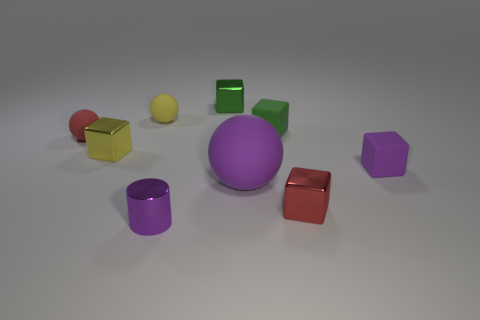Is the number of yellow metallic things greater than the number of large green things?
Give a very brief answer. Yes. There is a tiny matte sphere that is to the right of the yellow metallic object; what is its color?
Provide a succinct answer. Yellow. What size is the matte object that is both behind the small red sphere and to the right of the purple metallic cylinder?
Your answer should be very brief. Small. How many brown shiny cylinders are the same size as the purple matte cube?
Your answer should be very brief. 0. There is a red thing that is the same shape as the green metallic object; what is its material?
Your response must be concise. Metal. Is the shape of the yellow metal object the same as the big rubber object?
Provide a succinct answer. No. There is a small cylinder; how many red things are left of it?
Ensure brevity in your answer.  1. The tiny purple thing to the left of the small green metallic block right of the yellow ball is what shape?
Offer a very short reply. Cylinder. The tiny yellow thing that is made of the same material as the purple cube is what shape?
Give a very brief answer. Sphere. There is a metal block that is in front of the tiny yellow shiny block; does it have the same size as the green object that is left of the large purple matte ball?
Your answer should be compact. Yes. 